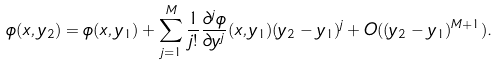<formula> <loc_0><loc_0><loc_500><loc_500>\phi ( x , y _ { 2 } ) = \phi ( x , y _ { 1 } ) + \sum _ { j = 1 } ^ { M } \frac { 1 } { j ! } \frac { \partial ^ { j } \phi } { \partial y ^ { j } } ( x , y _ { 1 } ) ( y _ { 2 } - y _ { 1 } ) ^ { j } + O ( ( y _ { 2 } - y _ { 1 } ) ^ { M + 1 } ) .</formula> 